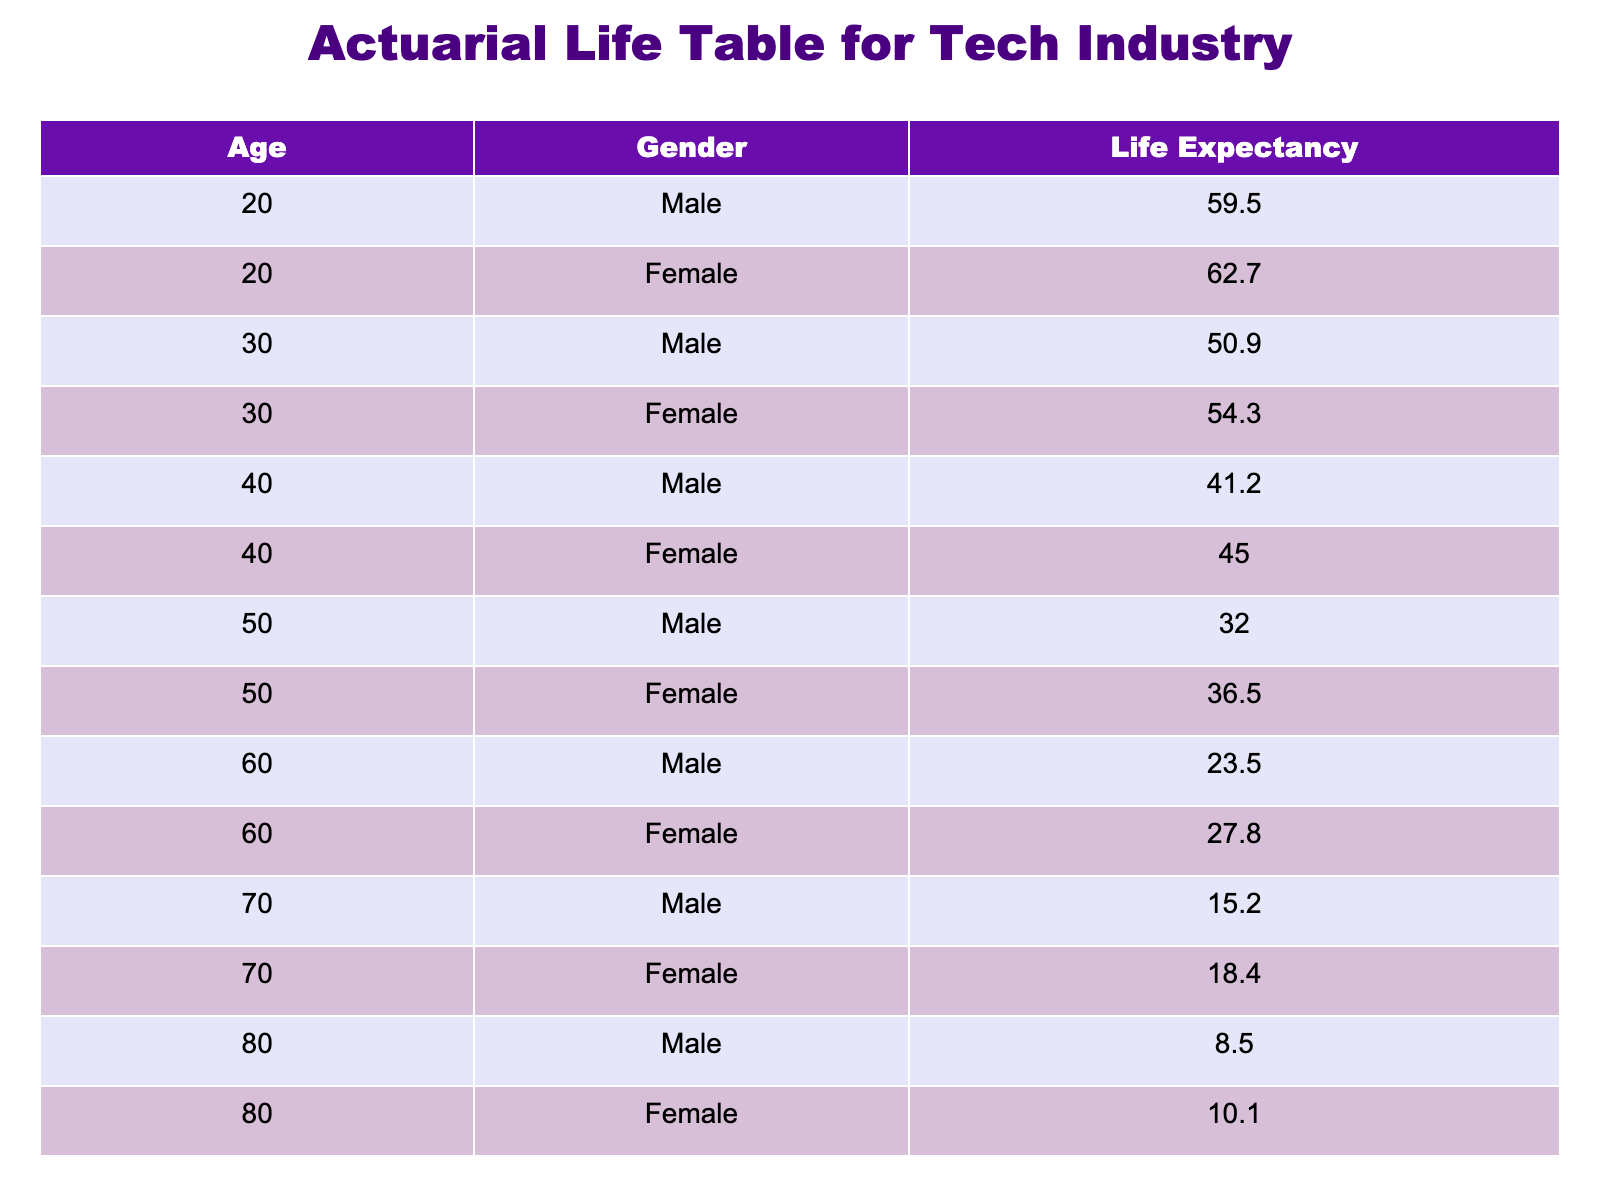What is the life expectancy for a 50-year-old male? According to the table, the life expectancy for a 50-year-old male is listed directly under the corresponding age and gender. The entry shows 32.0 years.
Answer: 32.0 What is the life expectancy difference between 30-year-old males and females? For 30-year-old males, the life expectancy is 50.9 years, while for females it is 54.3 years. To find the difference, we subtract the male life expectancy from the female life expectancy: 54.3 - 50.9 = 3.4 years.
Answer: 3.4 Is the life expectancy for 40-year-old females greater than that of 60-year-old males? The life expectancy for 40-year-old females is 45.0 years, while for 60-year-old males it is 23.5 years. Since 45.0 is greater than 23.5, the statement is true.
Answer: Yes What is the average life expectancy for all 70-year-old individuals? The life expectancy for 70-year-old males is 15.2 years, and for females, it is 18.4 years. To find the average, we add the two values together: 15.2 + 18.4 = 33.6, and then divide by 2: 33.6 / 2 = 16.8 years.
Answer: 16.8 For females over the age of 50, what is their average life expectancy? The life expectancy for 50-year-old females is 36.5 years, for 60-year-old females is 27.8 years, for 70-year-old females is 18.4 years, and for 80-year-old females is 10.1 years. The average is calculated by adding these values: 36.5 + 27.8 + 18.4 + 10.1 = 92.8, and then dividing by 4: 92.8 / 4 = 23.2 years.
Answer: 23.2 What is the highest life expectancy value in the table, and for which gender and age? Scanning through the table, the highest life expectancy value is 62.7 years corresponding to a 20-year-old female.
Answer: 62.7 years for 20-year-old females 